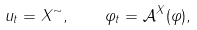<formula> <loc_0><loc_0><loc_500><loc_500>u _ { t } = X ^ { \sim } , \quad \varphi _ { t } = { \mathcal { A } } ^ { X } ( \varphi ) ,</formula> 